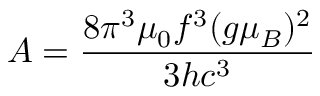<formula> <loc_0><loc_0><loc_500><loc_500>A = \frac { 8 \pi ^ { 3 } \mu _ { 0 } f ^ { 3 } ( g \mu _ { B } ) ^ { 2 } } { 3 h c ^ { 3 } }</formula> 